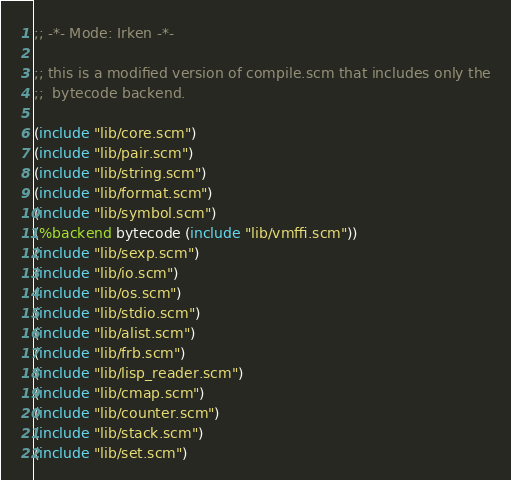<code> <loc_0><loc_0><loc_500><loc_500><_Scheme_>;; -*- Mode: Irken -*-

;; this is a modified version of compile.scm that includes only the
;;  bytecode backend.

(include "lib/core.scm")
(include "lib/pair.scm")
(include "lib/string.scm")
(include "lib/format.scm")
(include "lib/symbol.scm")
(%backend bytecode (include "lib/vmffi.scm"))
(include "lib/sexp.scm")
(include "lib/io.scm")
(include "lib/os.scm")
(include "lib/stdio.scm")
(include "lib/alist.scm")
(include "lib/frb.scm")
(include "lib/lisp_reader.scm")
(include "lib/cmap.scm")
(include "lib/counter.scm")
(include "lib/stack.scm")
(include "lib/set.scm")</code> 